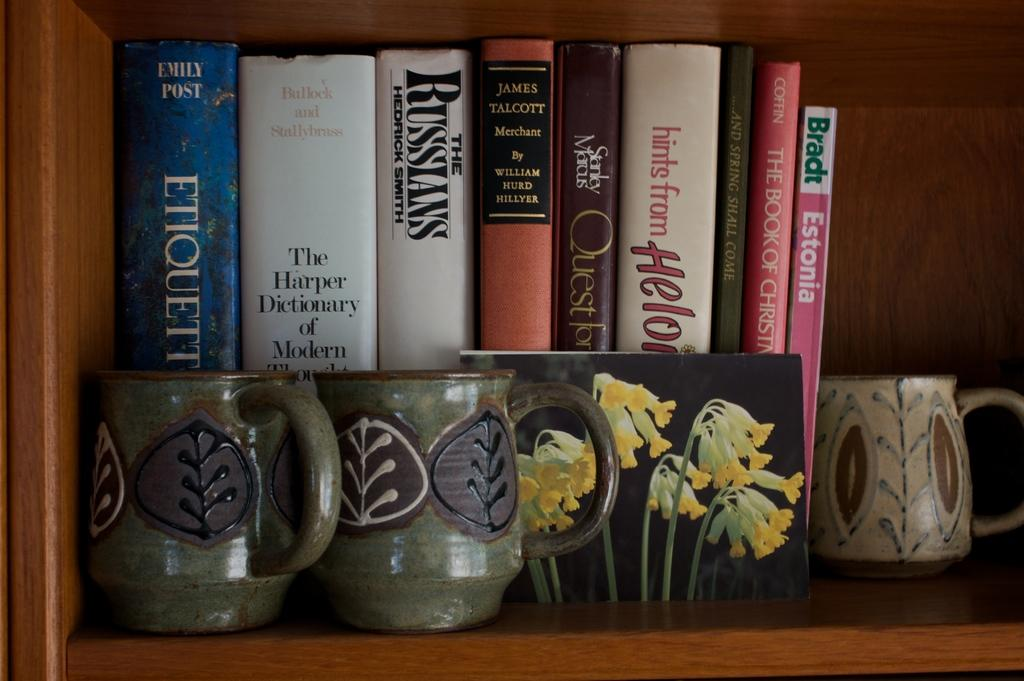<image>
Share a concise interpretation of the image provided. a book that says the Russians on it 